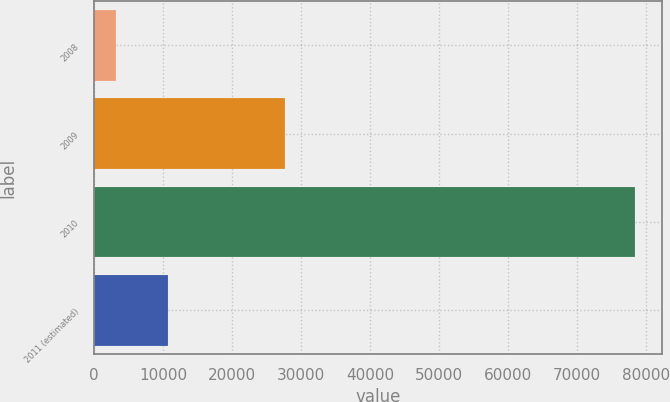<chart> <loc_0><loc_0><loc_500><loc_500><bar_chart><fcel>2008<fcel>2009<fcel>2010<fcel>2011 (estimated)<nl><fcel>3127<fcel>27616<fcel>78359<fcel>10650.2<nl></chart> 